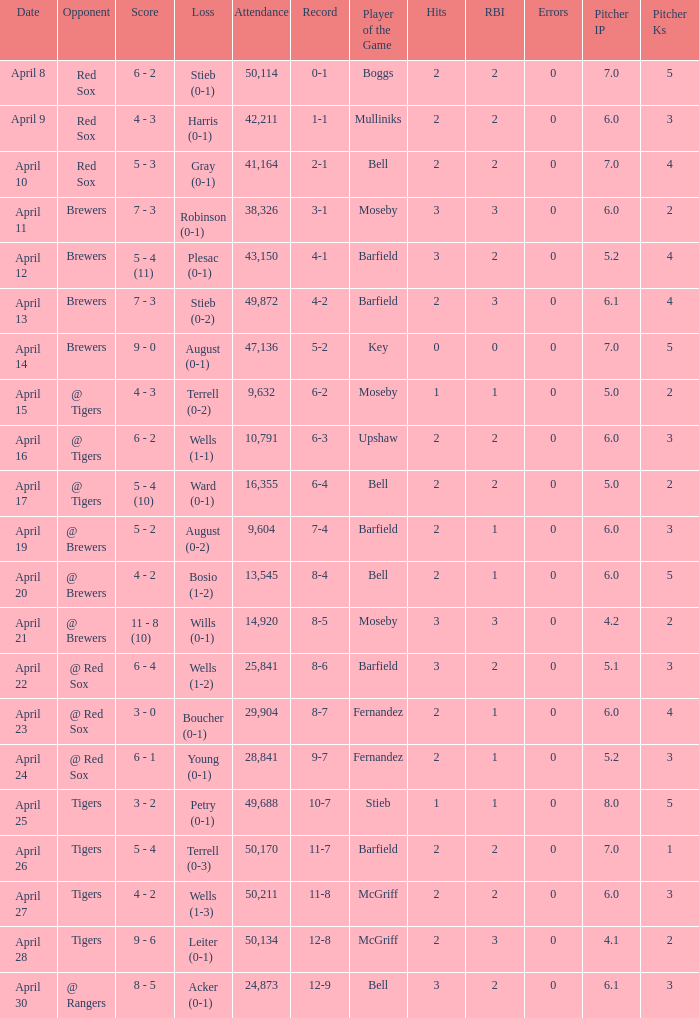Which opponent has a loss of wells (1-3)? Tigers. 